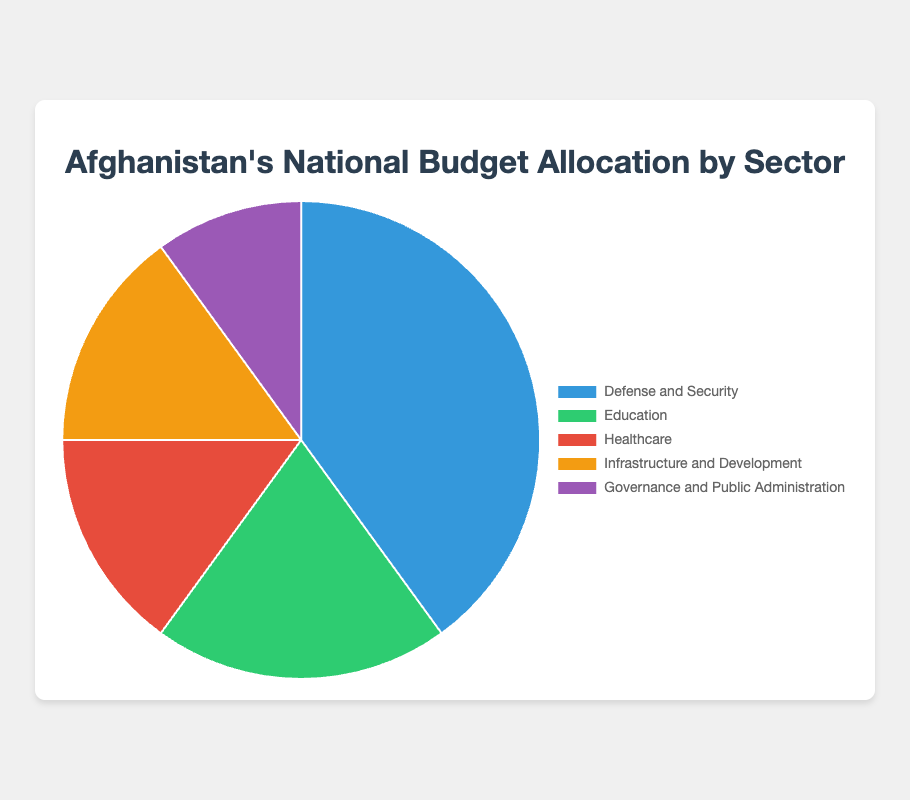Which sector receives the highest percentage of the budget? The pie chart shows five sectors with their respective percentage allocations. The sector with the largest segment is Defense and Security, which is 40%.
Answer: Defense and Security How much more is allocated to Defense and Security compared to Education? The percentage for Defense and Security is 40%, and for Education, it's 20%. The difference between them is calculated by subtracting the Education percentage from the Defense and Security percentage: 40% - 20% = 20%.
Answer: 20% What is the combined percentage allocation for Healthcare and Infrastructure and Development? The percentage for Healthcare is 15%, and for Infrastructure and Development, it's also 15%. Adding these two percentages together gives 15% + 15% = 30%.
Answer: 30% Which sector has the smallest budget allocation? By comparing all the percentages, Governance and Public Administration has the smallest allocation, which is 10%.
Answer: Governance and Public Administration Compare the sum of percentages allocated to Education and Healthcare to the percentage allocated to Defense and Security. Which is greater? The sum of the percentages allocated to Education and Healthcare is 20% + 15% = 35%. The percentage allocated to Defense and Security is 40%. Comparing both, 40% is greater than 35%.
Answer: Defense and Security What percentage of the budget is allocated to sectors other than Defense and Security? To find the percentage allocated to sectors other than Defense and Security, we subtract the percentage of Defense and Security from 100%: 100% - 40% = 60%.
Answer: 60% Which sector is represented by the green segment of the pie chart? The green segment of the pie chart corresponds to the Education sector.
Answer: Education How does the allocation to Healthcare compare to Governance and Public Administration? The Healthcare sector has an allocation of 15%, while Governance and Public Administration has 10%. Therefore, Healthcare has a higher allocation by 5%.
Answer: Healthcare If the budget for Education were increased by 10%, what would the new percentage be? The current percentage for Education is 20%. Adding 10% to this would give the new percentage, which is 20% + 10% = 30%.
Answer: 30% What is the ratio of the budget allocated to Infrastructure and Development versus Healthcare? Both Infrastructure and Development and Healthcare have the same budget allocation, which is 15%. Therefore, the ratio is 15%:15%, reduced to 1:1.
Answer: 1:1 